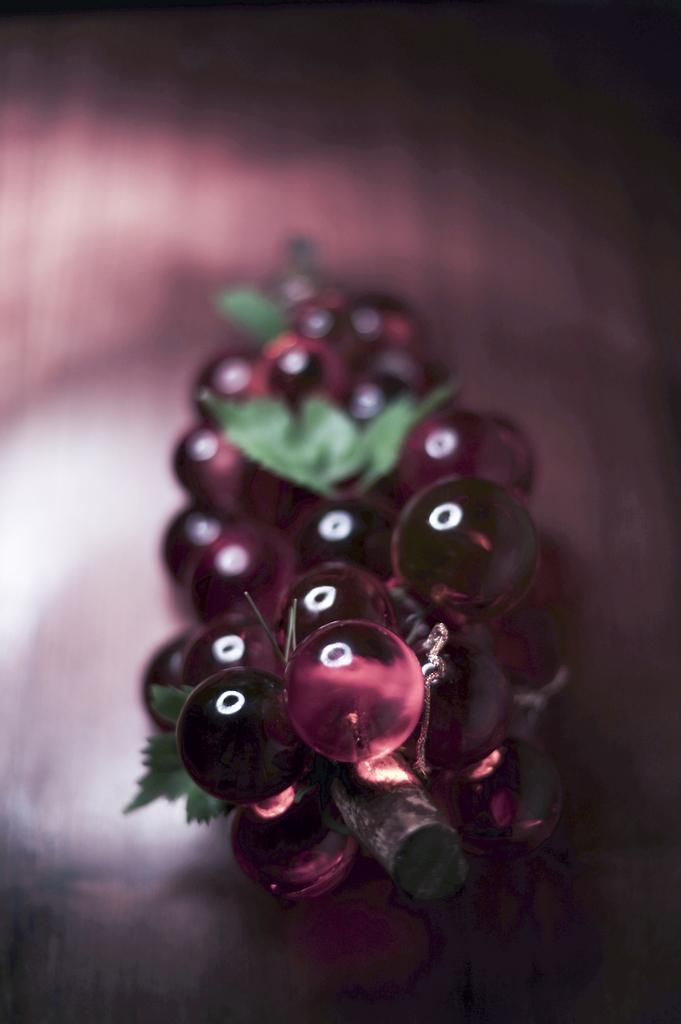What type of food can be seen in the image? There are fruits in the image. What else is present in the image besides the fruits? There are leaves in the image. Can you describe the background of the image? The background of the image is blurry. Where is the cave located in the image? There is no cave present in the image. What type of honey can be seen dripping from the fruits in the image? There is no honey present in the image; it only features fruits and leaves. 